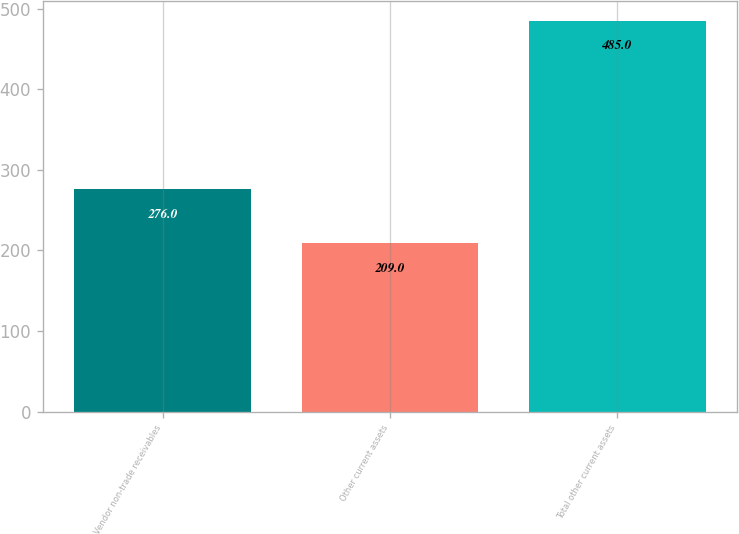Convert chart to OTSL. <chart><loc_0><loc_0><loc_500><loc_500><bar_chart><fcel>Vendor non-trade receivables<fcel>Other current assets<fcel>Total other current assets<nl><fcel>276<fcel>209<fcel>485<nl></chart> 